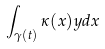Convert formula to latex. <formula><loc_0><loc_0><loc_500><loc_500>\int _ { \gamma ( t ) } \kappa ( x ) y d x</formula> 